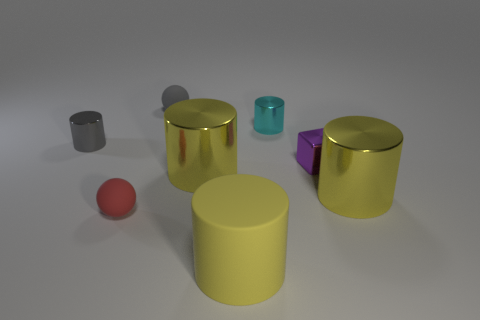The tiny rubber sphere that is in front of the tiny gray object behind the tiny gray cylinder is what color?
Offer a very short reply. Red. There is a large object that is to the right of the big matte object; what is it made of?
Provide a short and direct response. Metal. Is the number of big red rubber cubes less than the number of gray matte things?
Your answer should be compact. Yes. Do the tiny red rubber object and the tiny gray object behind the tiny cyan cylinder have the same shape?
Give a very brief answer. Yes. What is the shape of the tiny metal object that is both right of the gray rubber object and on the left side of the tiny cube?
Offer a terse response. Cylinder. Are there an equal number of tiny gray rubber balls that are right of the tiny cyan metallic object and cylinders that are right of the small gray cylinder?
Your answer should be compact. No. Does the yellow shiny thing that is to the right of the purple thing have the same shape as the cyan object?
Offer a very short reply. Yes. How many purple objects are metal cubes or big shiny things?
Offer a terse response. 1. There is another gray thing that is the same shape as the big rubber object; what is its material?
Provide a succinct answer. Metal. What shape is the big yellow metallic object that is on the right side of the yellow rubber cylinder?
Keep it short and to the point. Cylinder. 